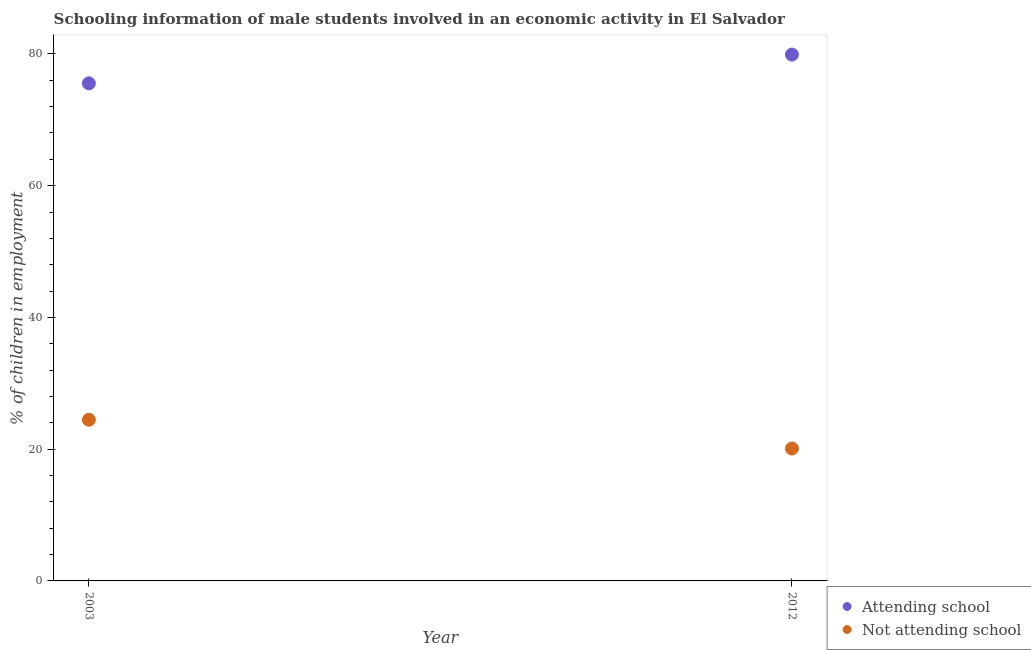How many different coloured dotlines are there?
Your answer should be very brief. 2. Is the number of dotlines equal to the number of legend labels?
Give a very brief answer. Yes. What is the percentage of employed males who are attending school in 2012?
Provide a short and direct response. 79.9. Across all years, what is the maximum percentage of employed males who are not attending school?
Your answer should be compact. 24.47. Across all years, what is the minimum percentage of employed males who are attending school?
Your response must be concise. 75.53. In which year was the percentage of employed males who are attending school maximum?
Give a very brief answer. 2012. What is the total percentage of employed males who are not attending school in the graph?
Make the answer very short. 44.57. What is the difference between the percentage of employed males who are attending school in 2003 and that in 2012?
Provide a succinct answer. -4.37. What is the difference between the percentage of employed males who are not attending school in 2003 and the percentage of employed males who are attending school in 2012?
Give a very brief answer. -55.43. What is the average percentage of employed males who are attending school per year?
Give a very brief answer. 77.72. In the year 2012, what is the difference between the percentage of employed males who are attending school and percentage of employed males who are not attending school?
Your answer should be compact. 59.8. In how many years, is the percentage of employed males who are not attending school greater than 60 %?
Provide a short and direct response. 0. What is the ratio of the percentage of employed males who are not attending school in 2003 to that in 2012?
Provide a short and direct response. 1.22. Is the percentage of employed males who are attending school in 2003 less than that in 2012?
Offer a very short reply. Yes. Does the percentage of employed males who are not attending school monotonically increase over the years?
Ensure brevity in your answer.  No. Is the percentage of employed males who are attending school strictly less than the percentage of employed males who are not attending school over the years?
Provide a succinct answer. No. Does the graph contain any zero values?
Your response must be concise. No. Where does the legend appear in the graph?
Ensure brevity in your answer.  Bottom right. How are the legend labels stacked?
Your answer should be compact. Vertical. What is the title of the graph?
Give a very brief answer. Schooling information of male students involved in an economic activity in El Salvador. What is the label or title of the X-axis?
Keep it short and to the point. Year. What is the label or title of the Y-axis?
Your response must be concise. % of children in employment. What is the % of children in employment of Attending school in 2003?
Make the answer very short. 75.53. What is the % of children in employment of Not attending school in 2003?
Provide a short and direct response. 24.47. What is the % of children in employment in Attending school in 2012?
Your answer should be very brief. 79.9. What is the % of children in employment in Not attending school in 2012?
Keep it short and to the point. 20.1. Across all years, what is the maximum % of children in employment in Attending school?
Your response must be concise. 79.9. Across all years, what is the maximum % of children in employment of Not attending school?
Offer a very short reply. 24.47. Across all years, what is the minimum % of children in employment of Attending school?
Offer a terse response. 75.53. Across all years, what is the minimum % of children in employment in Not attending school?
Your answer should be very brief. 20.1. What is the total % of children in employment in Attending school in the graph?
Offer a very short reply. 155.43. What is the total % of children in employment of Not attending school in the graph?
Your response must be concise. 44.57. What is the difference between the % of children in employment in Attending school in 2003 and that in 2012?
Offer a terse response. -4.37. What is the difference between the % of children in employment in Not attending school in 2003 and that in 2012?
Keep it short and to the point. 4.37. What is the difference between the % of children in employment of Attending school in 2003 and the % of children in employment of Not attending school in 2012?
Provide a succinct answer. 55.43. What is the average % of children in employment in Attending school per year?
Provide a short and direct response. 77.72. What is the average % of children in employment in Not attending school per year?
Offer a terse response. 22.28. In the year 2003, what is the difference between the % of children in employment in Attending school and % of children in employment in Not attending school?
Make the answer very short. 51.07. In the year 2012, what is the difference between the % of children in employment of Attending school and % of children in employment of Not attending school?
Offer a terse response. 59.8. What is the ratio of the % of children in employment in Attending school in 2003 to that in 2012?
Your answer should be compact. 0.95. What is the ratio of the % of children in employment of Not attending school in 2003 to that in 2012?
Ensure brevity in your answer.  1.22. What is the difference between the highest and the second highest % of children in employment in Attending school?
Make the answer very short. 4.37. What is the difference between the highest and the second highest % of children in employment of Not attending school?
Offer a very short reply. 4.37. What is the difference between the highest and the lowest % of children in employment of Attending school?
Your answer should be very brief. 4.37. What is the difference between the highest and the lowest % of children in employment of Not attending school?
Ensure brevity in your answer.  4.37. 